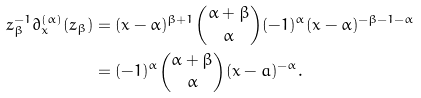<formula> <loc_0><loc_0><loc_500><loc_500>z ^ { - 1 } _ { \beta } \partial ^ { ( \alpha ) } _ { x } ( z _ { \beta } ) & = ( x - \alpha ) ^ { \beta + 1 } \binom { \alpha + \beta } { \alpha } ( - 1 ) ^ { \alpha } ( x - \alpha ) ^ { - \beta - 1 - \alpha } \\ & = ( - 1 ) ^ { \alpha } \binom { \alpha + \beta } { \alpha } ( x - a ) ^ { - \alpha } .</formula> 